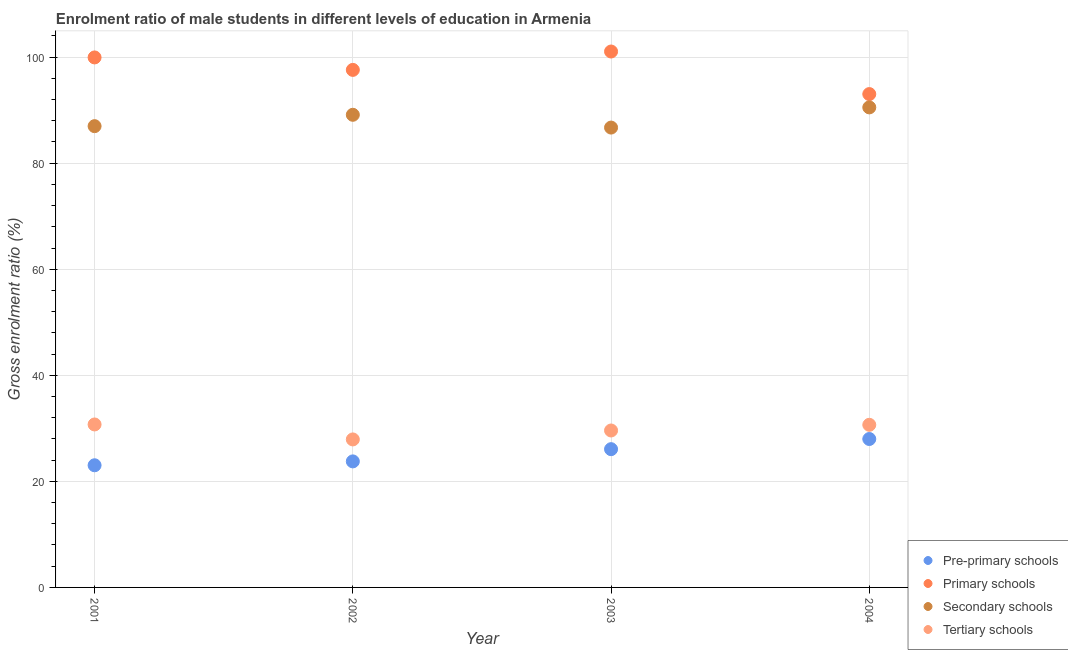How many different coloured dotlines are there?
Your answer should be very brief. 4. Is the number of dotlines equal to the number of legend labels?
Provide a succinct answer. Yes. What is the gross enrolment ratio(female) in primary schools in 2004?
Your answer should be compact. 93.03. Across all years, what is the maximum gross enrolment ratio(female) in tertiary schools?
Your response must be concise. 30.73. Across all years, what is the minimum gross enrolment ratio(female) in tertiary schools?
Provide a short and direct response. 27.91. In which year was the gross enrolment ratio(female) in secondary schools minimum?
Make the answer very short. 2003. What is the total gross enrolment ratio(female) in pre-primary schools in the graph?
Your answer should be very brief. 100.86. What is the difference between the gross enrolment ratio(female) in primary schools in 2002 and that in 2004?
Your answer should be very brief. 4.56. What is the difference between the gross enrolment ratio(female) in tertiary schools in 2001 and the gross enrolment ratio(female) in pre-primary schools in 2002?
Make the answer very short. 6.96. What is the average gross enrolment ratio(female) in tertiary schools per year?
Make the answer very short. 29.72. In the year 2001, what is the difference between the gross enrolment ratio(female) in secondary schools and gross enrolment ratio(female) in tertiary schools?
Your answer should be very brief. 56.25. In how many years, is the gross enrolment ratio(female) in primary schools greater than 60 %?
Your answer should be compact. 4. What is the ratio of the gross enrolment ratio(female) in pre-primary schools in 2002 to that in 2003?
Your response must be concise. 0.91. Is the gross enrolment ratio(female) in primary schools in 2001 less than that in 2002?
Your answer should be compact. No. What is the difference between the highest and the second highest gross enrolment ratio(female) in primary schools?
Provide a succinct answer. 1.12. What is the difference between the highest and the lowest gross enrolment ratio(female) in primary schools?
Offer a terse response. 8.03. In how many years, is the gross enrolment ratio(female) in tertiary schools greater than the average gross enrolment ratio(female) in tertiary schools taken over all years?
Make the answer very short. 2. Is it the case that in every year, the sum of the gross enrolment ratio(female) in tertiary schools and gross enrolment ratio(female) in pre-primary schools is greater than the sum of gross enrolment ratio(female) in primary schools and gross enrolment ratio(female) in secondary schools?
Your response must be concise. No. Does the gross enrolment ratio(female) in primary schools monotonically increase over the years?
Provide a short and direct response. No. What is the difference between two consecutive major ticks on the Y-axis?
Ensure brevity in your answer.  20. Does the graph contain any zero values?
Your response must be concise. No. How many legend labels are there?
Provide a short and direct response. 4. How are the legend labels stacked?
Make the answer very short. Vertical. What is the title of the graph?
Provide a succinct answer. Enrolment ratio of male students in different levels of education in Armenia. Does "Taxes on exports" appear as one of the legend labels in the graph?
Keep it short and to the point. No. What is the label or title of the X-axis?
Your response must be concise. Year. What is the label or title of the Y-axis?
Give a very brief answer. Gross enrolment ratio (%). What is the Gross enrolment ratio (%) of Pre-primary schools in 2001?
Ensure brevity in your answer.  23.03. What is the Gross enrolment ratio (%) of Primary schools in 2001?
Keep it short and to the point. 99.94. What is the Gross enrolment ratio (%) in Secondary schools in 2001?
Provide a succinct answer. 86.98. What is the Gross enrolment ratio (%) of Tertiary schools in 2001?
Make the answer very short. 30.73. What is the Gross enrolment ratio (%) in Pre-primary schools in 2002?
Your answer should be very brief. 23.77. What is the Gross enrolment ratio (%) of Primary schools in 2002?
Your answer should be very brief. 97.59. What is the Gross enrolment ratio (%) of Secondary schools in 2002?
Provide a short and direct response. 89.12. What is the Gross enrolment ratio (%) in Tertiary schools in 2002?
Provide a succinct answer. 27.91. What is the Gross enrolment ratio (%) of Pre-primary schools in 2003?
Ensure brevity in your answer.  26.07. What is the Gross enrolment ratio (%) of Primary schools in 2003?
Provide a short and direct response. 101.05. What is the Gross enrolment ratio (%) in Secondary schools in 2003?
Offer a very short reply. 86.71. What is the Gross enrolment ratio (%) in Tertiary schools in 2003?
Your answer should be compact. 29.59. What is the Gross enrolment ratio (%) of Pre-primary schools in 2004?
Provide a short and direct response. 27.99. What is the Gross enrolment ratio (%) of Primary schools in 2004?
Ensure brevity in your answer.  93.03. What is the Gross enrolment ratio (%) of Secondary schools in 2004?
Your answer should be very brief. 90.51. What is the Gross enrolment ratio (%) in Tertiary schools in 2004?
Ensure brevity in your answer.  30.66. Across all years, what is the maximum Gross enrolment ratio (%) of Pre-primary schools?
Keep it short and to the point. 27.99. Across all years, what is the maximum Gross enrolment ratio (%) in Primary schools?
Offer a terse response. 101.05. Across all years, what is the maximum Gross enrolment ratio (%) of Secondary schools?
Ensure brevity in your answer.  90.51. Across all years, what is the maximum Gross enrolment ratio (%) of Tertiary schools?
Ensure brevity in your answer.  30.73. Across all years, what is the minimum Gross enrolment ratio (%) of Pre-primary schools?
Provide a short and direct response. 23.03. Across all years, what is the minimum Gross enrolment ratio (%) in Primary schools?
Give a very brief answer. 93.03. Across all years, what is the minimum Gross enrolment ratio (%) in Secondary schools?
Make the answer very short. 86.71. Across all years, what is the minimum Gross enrolment ratio (%) of Tertiary schools?
Your answer should be very brief. 27.91. What is the total Gross enrolment ratio (%) in Pre-primary schools in the graph?
Ensure brevity in your answer.  100.86. What is the total Gross enrolment ratio (%) of Primary schools in the graph?
Offer a terse response. 391.6. What is the total Gross enrolment ratio (%) of Secondary schools in the graph?
Provide a short and direct response. 353.32. What is the total Gross enrolment ratio (%) in Tertiary schools in the graph?
Provide a succinct answer. 118.89. What is the difference between the Gross enrolment ratio (%) of Pre-primary schools in 2001 and that in 2002?
Give a very brief answer. -0.73. What is the difference between the Gross enrolment ratio (%) in Primary schools in 2001 and that in 2002?
Your answer should be very brief. 2.35. What is the difference between the Gross enrolment ratio (%) of Secondary schools in 2001 and that in 2002?
Make the answer very short. -2.14. What is the difference between the Gross enrolment ratio (%) of Tertiary schools in 2001 and that in 2002?
Your answer should be compact. 2.82. What is the difference between the Gross enrolment ratio (%) in Pre-primary schools in 2001 and that in 2003?
Keep it short and to the point. -3.04. What is the difference between the Gross enrolment ratio (%) in Primary schools in 2001 and that in 2003?
Your response must be concise. -1.12. What is the difference between the Gross enrolment ratio (%) in Secondary schools in 2001 and that in 2003?
Keep it short and to the point. 0.27. What is the difference between the Gross enrolment ratio (%) in Tertiary schools in 2001 and that in 2003?
Your answer should be compact. 1.14. What is the difference between the Gross enrolment ratio (%) in Pre-primary schools in 2001 and that in 2004?
Offer a very short reply. -4.95. What is the difference between the Gross enrolment ratio (%) in Primary schools in 2001 and that in 2004?
Ensure brevity in your answer.  6.91. What is the difference between the Gross enrolment ratio (%) of Secondary schools in 2001 and that in 2004?
Your response must be concise. -3.54. What is the difference between the Gross enrolment ratio (%) of Tertiary schools in 2001 and that in 2004?
Provide a short and direct response. 0.06. What is the difference between the Gross enrolment ratio (%) of Pre-primary schools in 2002 and that in 2003?
Your answer should be compact. -2.31. What is the difference between the Gross enrolment ratio (%) in Primary schools in 2002 and that in 2003?
Provide a succinct answer. -3.47. What is the difference between the Gross enrolment ratio (%) in Secondary schools in 2002 and that in 2003?
Your answer should be very brief. 2.41. What is the difference between the Gross enrolment ratio (%) of Tertiary schools in 2002 and that in 2003?
Your answer should be very brief. -1.68. What is the difference between the Gross enrolment ratio (%) in Pre-primary schools in 2002 and that in 2004?
Offer a very short reply. -4.22. What is the difference between the Gross enrolment ratio (%) in Primary schools in 2002 and that in 2004?
Provide a succinct answer. 4.56. What is the difference between the Gross enrolment ratio (%) in Secondary schools in 2002 and that in 2004?
Your answer should be compact. -1.39. What is the difference between the Gross enrolment ratio (%) of Tertiary schools in 2002 and that in 2004?
Offer a terse response. -2.76. What is the difference between the Gross enrolment ratio (%) in Pre-primary schools in 2003 and that in 2004?
Your answer should be very brief. -1.92. What is the difference between the Gross enrolment ratio (%) of Primary schools in 2003 and that in 2004?
Ensure brevity in your answer.  8.03. What is the difference between the Gross enrolment ratio (%) of Secondary schools in 2003 and that in 2004?
Give a very brief answer. -3.8. What is the difference between the Gross enrolment ratio (%) in Tertiary schools in 2003 and that in 2004?
Offer a terse response. -1.07. What is the difference between the Gross enrolment ratio (%) of Pre-primary schools in 2001 and the Gross enrolment ratio (%) of Primary schools in 2002?
Give a very brief answer. -74.55. What is the difference between the Gross enrolment ratio (%) in Pre-primary schools in 2001 and the Gross enrolment ratio (%) in Secondary schools in 2002?
Provide a succinct answer. -66.09. What is the difference between the Gross enrolment ratio (%) of Pre-primary schools in 2001 and the Gross enrolment ratio (%) of Tertiary schools in 2002?
Offer a very short reply. -4.87. What is the difference between the Gross enrolment ratio (%) in Primary schools in 2001 and the Gross enrolment ratio (%) in Secondary schools in 2002?
Provide a succinct answer. 10.82. What is the difference between the Gross enrolment ratio (%) of Primary schools in 2001 and the Gross enrolment ratio (%) of Tertiary schools in 2002?
Your answer should be very brief. 72.03. What is the difference between the Gross enrolment ratio (%) of Secondary schools in 2001 and the Gross enrolment ratio (%) of Tertiary schools in 2002?
Your answer should be compact. 59.07. What is the difference between the Gross enrolment ratio (%) in Pre-primary schools in 2001 and the Gross enrolment ratio (%) in Primary schools in 2003?
Give a very brief answer. -78.02. What is the difference between the Gross enrolment ratio (%) in Pre-primary schools in 2001 and the Gross enrolment ratio (%) in Secondary schools in 2003?
Keep it short and to the point. -63.68. What is the difference between the Gross enrolment ratio (%) of Pre-primary schools in 2001 and the Gross enrolment ratio (%) of Tertiary schools in 2003?
Provide a short and direct response. -6.56. What is the difference between the Gross enrolment ratio (%) of Primary schools in 2001 and the Gross enrolment ratio (%) of Secondary schools in 2003?
Ensure brevity in your answer.  13.23. What is the difference between the Gross enrolment ratio (%) of Primary schools in 2001 and the Gross enrolment ratio (%) of Tertiary schools in 2003?
Your answer should be very brief. 70.34. What is the difference between the Gross enrolment ratio (%) of Secondary schools in 2001 and the Gross enrolment ratio (%) of Tertiary schools in 2003?
Offer a very short reply. 57.39. What is the difference between the Gross enrolment ratio (%) in Pre-primary schools in 2001 and the Gross enrolment ratio (%) in Primary schools in 2004?
Make the answer very short. -69.99. What is the difference between the Gross enrolment ratio (%) in Pre-primary schools in 2001 and the Gross enrolment ratio (%) in Secondary schools in 2004?
Offer a very short reply. -67.48. What is the difference between the Gross enrolment ratio (%) of Pre-primary schools in 2001 and the Gross enrolment ratio (%) of Tertiary schools in 2004?
Provide a succinct answer. -7.63. What is the difference between the Gross enrolment ratio (%) of Primary schools in 2001 and the Gross enrolment ratio (%) of Secondary schools in 2004?
Your response must be concise. 9.42. What is the difference between the Gross enrolment ratio (%) in Primary schools in 2001 and the Gross enrolment ratio (%) in Tertiary schools in 2004?
Offer a very short reply. 69.27. What is the difference between the Gross enrolment ratio (%) in Secondary schools in 2001 and the Gross enrolment ratio (%) in Tertiary schools in 2004?
Make the answer very short. 56.31. What is the difference between the Gross enrolment ratio (%) of Pre-primary schools in 2002 and the Gross enrolment ratio (%) of Primary schools in 2003?
Your answer should be very brief. -77.29. What is the difference between the Gross enrolment ratio (%) of Pre-primary schools in 2002 and the Gross enrolment ratio (%) of Secondary schools in 2003?
Your answer should be very brief. -62.95. What is the difference between the Gross enrolment ratio (%) of Pre-primary schools in 2002 and the Gross enrolment ratio (%) of Tertiary schools in 2003?
Make the answer very short. -5.83. What is the difference between the Gross enrolment ratio (%) in Primary schools in 2002 and the Gross enrolment ratio (%) in Secondary schools in 2003?
Provide a short and direct response. 10.88. What is the difference between the Gross enrolment ratio (%) in Primary schools in 2002 and the Gross enrolment ratio (%) in Tertiary schools in 2003?
Give a very brief answer. 67.99. What is the difference between the Gross enrolment ratio (%) in Secondary schools in 2002 and the Gross enrolment ratio (%) in Tertiary schools in 2003?
Ensure brevity in your answer.  59.53. What is the difference between the Gross enrolment ratio (%) of Pre-primary schools in 2002 and the Gross enrolment ratio (%) of Primary schools in 2004?
Keep it short and to the point. -69.26. What is the difference between the Gross enrolment ratio (%) of Pre-primary schools in 2002 and the Gross enrolment ratio (%) of Secondary schools in 2004?
Your response must be concise. -66.75. What is the difference between the Gross enrolment ratio (%) of Pre-primary schools in 2002 and the Gross enrolment ratio (%) of Tertiary schools in 2004?
Your answer should be compact. -6.9. What is the difference between the Gross enrolment ratio (%) in Primary schools in 2002 and the Gross enrolment ratio (%) in Secondary schools in 2004?
Keep it short and to the point. 7.07. What is the difference between the Gross enrolment ratio (%) of Primary schools in 2002 and the Gross enrolment ratio (%) of Tertiary schools in 2004?
Offer a terse response. 66.92. What is the difference between the Gross enrolment ratio (%) in Secondary schools in 2002 and the Gross enrolment ratio (%) in Tertiary schools in 2004?
Your answer should be compact. 58.46. What is the difference between the Gross enrolment ratio (%) of Pre-primary schools in 2003 and the Gross enrolment ratio (%) of Primary schools in 2004?
Provide a short and direct response. -66.96. What is the difference between the Gross enrolment ratio (%) of Pre-primary schools in 2003 and the Gross enrolment ratio (%) of Secondary schools in 2004?
Give a very brief answer. -64.44. What is the difference between the Gross enrolment ratio (%) of Pre-primary schools in 2003 and the Gross enrolment ratio (%) of Tertiary schools in 2004?
Your answer should be very brief. -4.59. What is the difference between the Gross enrolment ratio (%) of Primary schools in 2003 and the Gross enrolment ratio (%) of Secondary schools in 2004?
Offer a terse response. 10.54. What is the difference between the Gross enrolment ratio (%) of Primary schools in 2003 and the Gross enrolment ratio (%) of Tertiary schools in 2004?
Offer a terse response. 70.39. What is the difference between the Gross enrolment ratio (%) of Secondary schools in 2003 and the Gross enrolment ratio (%) of Tertiary schools in 2004?
Provide a short and direct response. 56.05. What is the average Gross enrolment ratio (%) of Pre-primary schools per year?
Offer a terse response. 25.21. What is the average Gross enrolment ratio (%) in Primary schools per year?
Your response must be concise. 97.9. What is the average Gross enrolment ratio (%) in Secondary schools per year?
Provide a succinct answer. 88.33. What is the average Gross enrolment ratio (%) of Tertiary schools per year?
Offer a very short reply. 29.72. In the year 2001, what is the difference between the Gross enrolment ratio (%) of Pre-primary schools and Gross enrolment ratio (%) of Primary schools?
Your response must be concise. -76.9. In the year 2001, what is the difference between the Gross enrolment ratio (%) in Pre-primary schools and Gross enrolment ratio (%) in Secondary schools?
Keep it short and to the point. -63.94. In the year 2001, what is the difference between the Gross enrolment ratio (%) of Pre-primary schools and Gross enrolment ratio (%) of Tertiary schools?
Your response must be concise. -7.69. In the year 2001, what is the difference between the Gross enrolment ratio (%) in Primary schools and Gross enrolment ratio (%) in Secondary schools?
Provide a short and direct response. 12.96. In the year 2001, what is the difference between the Gross enrolment ratio (%) of Primary schools and Gross enrolment ratio (%) of Tertiary schools?
Offer a very short reply. 69.21. In the year 2001, what is the difference between the Gross enrolment ratio (%) in Secondary schools and Gross enrolment ratio (%) in Tertiary schools?
Provide a succinct answer. 56.25. In the year 2002, what is the difference between the Gross enrolment ratio (%) in Pre-primary schools and Gross enrolment ratio (%) in Primary schools?
Provide a short and direct response. -73.82. In the year 2002, what is the difference between the Gross enrolment ratio (%) of Pre-primary schools and Gross enrolment ratio (%) of Secondary schools?
Give a very brief answer. -65.35. In the year 2002, what is the difference between the Gross enrolment ratio (%) of Pre-primary schools and Gross enrolment ratio (%) of Tertiary schools?
Make the answer very short. -4.14. In the year 2002, what is the difference between the Gross enrolment ratio (%) of Primary schools and Gross enrolment ratio (%) of Secondary schools?
Your answer should be compact. 8.47. In the year 2002, what is the difference between the Gross enrolment ratio (%) in Primary schools and Gross enrolment ratio (%) in Tertiary schools?
Keep it short and to the point. 69.68. In the year 2002, what is the difference between the Gross enrolment ratio (%) in Secondary schools and Gross enrolment ratio (%) in Tertiary schools?
Your response must be concise. 61.21. In the year 2003, what is the difference between the Gross enrolment ratio (%) in Pre-primary schools and Gross enrolment ratio (%) in Primary schools?
Make the answer very short. -74.98. In the year 2003, what is the difference between the Gross enrolment ratio (%) in Pre-primary schools and Gross enrolment ratio (%) in Secondary schools?
Your response must be concise. -60.64. In the year 2003, what is the difference between the Gross enrolment ratio (%) in Pre-primary schools and Gross enrolment ratio (%) in Tertiary schools?
Keep it short and to the point. -3.52. In the year 2003, what is the difference between the Gross enrolment ratio (%) of Primary schools and Gross enrolment ratio (%) of Secondary schools?
Provide a succinct answer. 14.34. In the year 2003, what is the difference between the Gross enrolment ratio (%) in Primary schools and Gross enrolment ratio (%) in Tertiary schools?
Offer a very short reply. 71.46. In the year 2003, what is the difference between the Gross enrolment ratio (%) in Secondary schools and Gross enrolment ratio (%) in Tertiary schools?
Your response must be concise. 57.12. In the year 2004, what is the difference between the Gross enrolment ratio (%) of Pre-primary schools and Gross enrolment ratio (%) of Primary schools?
Your answer should be very brief. -65.04. In the year 2004, what is the difference between the Gross enrolment ratio (%) of Pre-primary schools and Gross enrolment ratio (%) of Secondary schools?
Give a very brief answer. -62.53. In the year 2004, what is the difference between the Gross enrolment ratio (%) in Pre-primary schools and Gross enrolment ratio (%) in Tertiary schools?
Ensure brevity in your answer.  -2.68. In the year 2004, what is the difference between the Gross enrolment ratio (%) of Primary schools and Gross enrolment ratio (%) of Secondary schools?
Ensure brevity in your answer.  2.51. In the year 2004, what is the difference between the Gross enrolment ratio (%) of Primary schools and Gross enrolment ratio (%) of Tertiary schools?
Provide a succinct answer. 62.36. In the year 2004, what is the difference between the Gross enrolment ratio (%) in Secondary schools and Gross enrolment ratio (%) in Tertiary schools?
Give a very brief answer. 59.85. What is the ratio of the Gross enrolment ratio (%) of Pre-primary schools in 2001 to that in 2002?
Your answer should be compact. 0.97. What is the ratio of the Gross enrolment ratio (%) of Primary schools in 2001 to that in 2002?
Your answer should be very brief. 1.02. What is the ratio of the Gross enrolment ratio (%) of Tertiary schools in 2001 to that in 2002?
Give a very brief answer. 1.1. What is the ratio of the Gross enrolment ratio (%) in Pre-primary schools in 2001 to that in 2003?
Offer a very short reply. 0.88. What is the ratio of the Gross enrolment ratio (%) in Primary schools in 2001 to that in 2003?
Keep it short and to the point. 0.99. What is the ratio of the Gross enrolment ratio (%) of Secondary schools in 2001 to that in 2003?
Your answer should be compact. 1. What is the ratio of the Gross enrolment ratio (%) in Tertiary schools in 2001 to that in 2003?
Your answer should be very brief. 1.04. What is the ratio of the Gross enrolment ratio (%) of Pre-primary schools in 2001 to that in 2004?
Your answer should be compact. 0.82. What is the ratio of the Gross enrolment ratio (%) in Primary schools in 2001 to that in 2004?
Keep it short and to the point. 1.07. What is the ratio of the Gross enrolment ratio (%) of Secondary schools in 2001 to that in 2004?
Provide a succinct answer. 0.96. What is the ratio of the Gross enrolment ratio (%) in Tertiary schools in 2001 to that in 2004?
Give a very brief answer. 1. What is the ratio of the Gross enrolment ratio (%) of Pre-primary schools in 2002 to that in 2003?
Ensure brevity in your answer.  0.91. What is the ratio of the Gross enrolment ratio (%) of Primary schools in 2002 to that in 2003?
Your response must be concise. 0.97. What is the ratio of the Gross enrolment ratio (%) of Secondary schools in 2002 to that in 2003?
Keep it short and to the point. 1.03. What is the ratio of the Gross enrolment ratio (%) of Tertiary schools in 2002 to that in 2003?
Make the answer very short. 0.94. What is the ratio of the Gross enrolment ratio (%) of Pre-primary schools in 2002 to that in 2004?
Provide a succinct answer. 0.85. What is the ratio of the Gross enrolment ratio (%) of Primary schools in 2002 to that in 2004?
Ensure brevity in your answer.  1.05. What is the ratio of the Gross enrolment ratio (%) in Secondary schools in 2002 to that in 2004?
Offer a terse response. 0.98. What is the ratio of the Gross enrolment ratio (%) in Tertiary schools in 2002 to that in 2004?
Your answer should be compact. 0.91. What is the ratio of the Gross enrolment ratio (%) in Pre-primary schools in 2003 to that in 2004?
Give a very brief answer. 0.93. What is the ratio of the Gross enrolment ratio (%) in Primary schools in 2003 to that in 2004?
Give a very brief answer. 1.09. What is the ratio of the Gross enrolment ratio (%) in Secondary schools in 2003 to that in 2004?
Offer a terse response. 0.96. What is the difference between the highest and the second highest Gross enrolment ratio (%) of Pre-primary schools?
Your answer should be compact. 1.92. What is the difference between the highest and the second highest Gross enrolment ratio (%) of Primary schools?
Your response must be concise. 1.12. What is the difference between the highest and the second highest Gross enrolment ratio (%) of Secondary schools?
Keep it short and to the point. 1.39. What is the difference between the highest and the second highest Gross enrolment ratio (%) in Tertiary schools?
Your response must be concise. 0.06. What is the difference between the highest and the lowest Gross enrolment ratio (%) of Pre-primary schools?
Ensure brevity in your answer.  4.95. What is the difference between the highest and the lowest Gross enrolment ratio (%) in Primary schools?
Ensure brevity in your answer.  8.03. What is the difference between the highest and the lowest Gross enrolment ratio (%) of Secondary schools?
Provide a succinct answer. 3.8. What is the difference between the highest and the lowest Gross enrolment ratio (%) in Tertiary schools?
Ensure brevity in your answer.  2.82. 